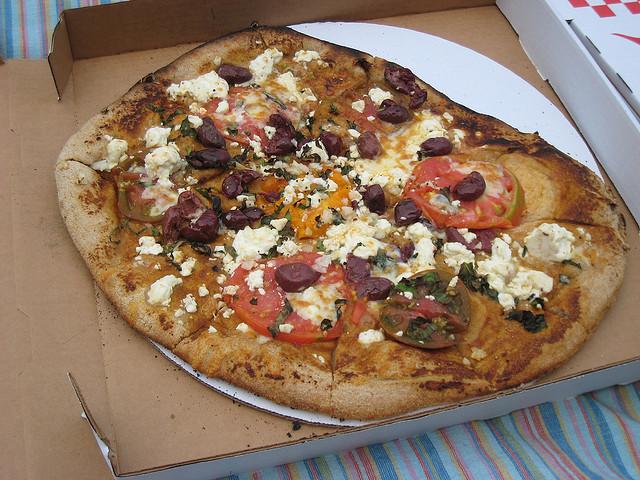Is this food symmetrical?
Short answer required. No. Is there a bottle behind the pizza?
Keep it brief. No. What meat is on the top?
Answer briefly. Sausage. What shape is the pizza?
Short answer required. Round. Is the pizza on a wooden table?
Short answer required. No. Does this pizza look delicious?
Write a very short answer. Yes. Is the pizza for a vegetarian?
Be succinct. Yes. Are there vegetables on the pizza?
Concise answer only. Yes. 